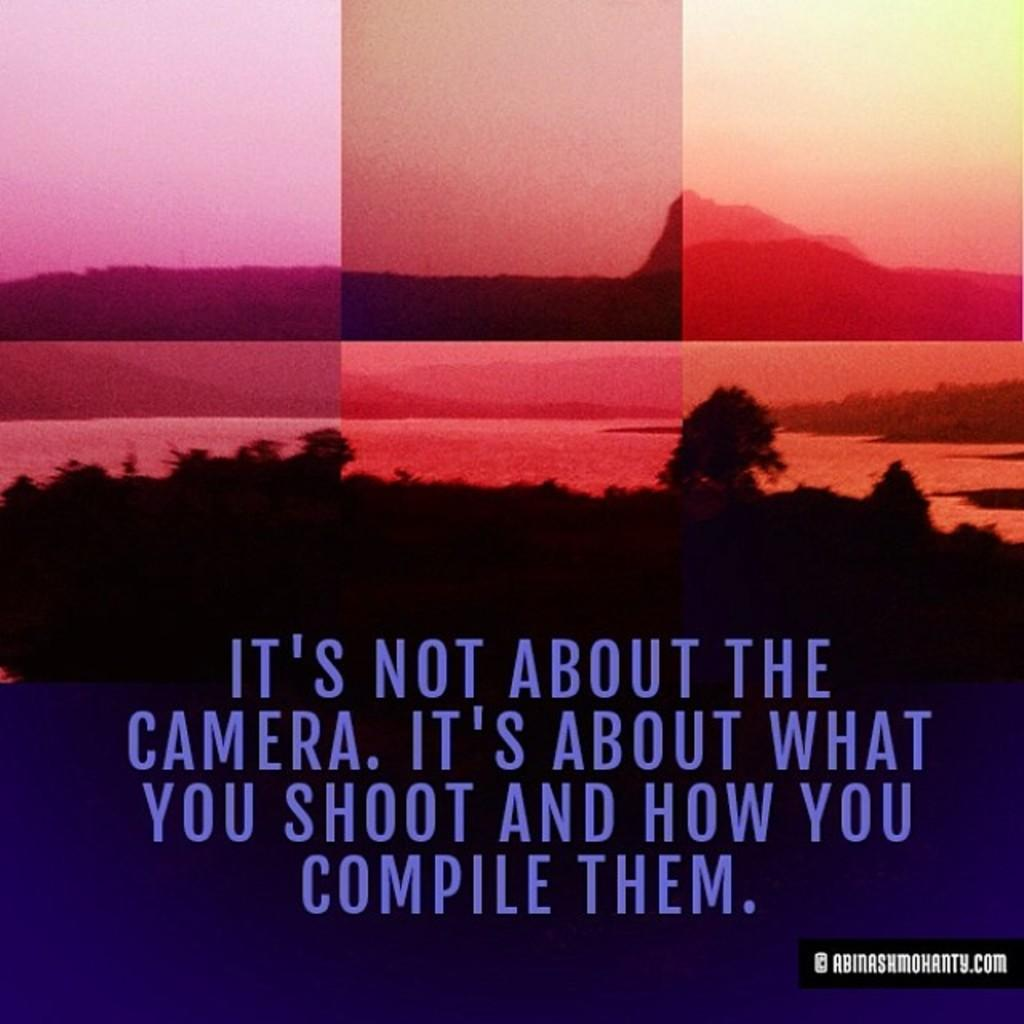Provide a one-sentence caption for the provided image. "It's not about the camera. It's about what you shoot and how you compile them"  with a scenic background that consists of a mountain, trees, and a lake. 